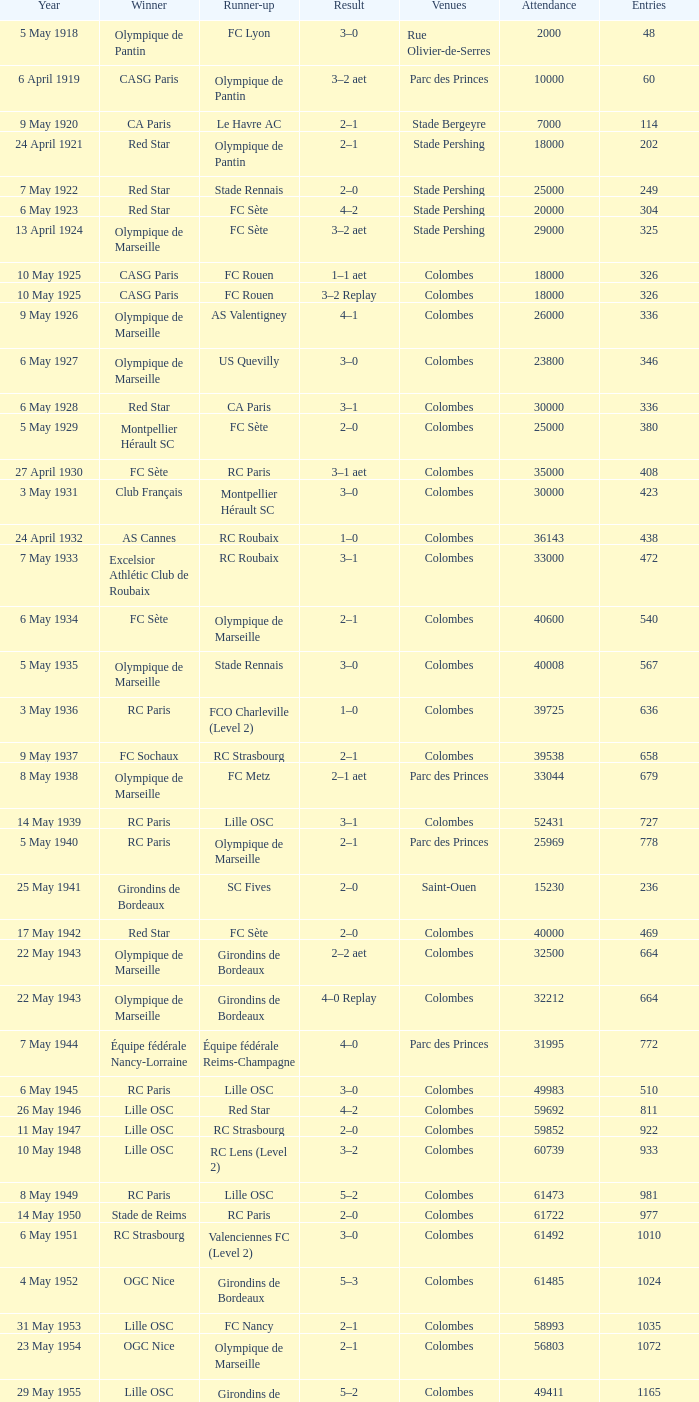How often has red star been the runner-up in games? 1.0. 